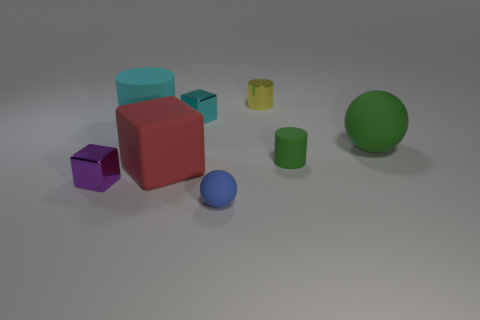Add 1 tiny metallic cylinders. How many objects exist? 9 Subtract all cubes. How many objects are left? 5 Add 2 cyan metallic objects. How many cyan metallic objects are left? 3 Add 1 cyan rubber cylinders. How many cyan rubber cylinders exist? 2 Subtract 0 gray cubes. How many objects are left? 8 Subtract all big red rubber things. Subtract all cyan matte things. How many objects are left? 6 